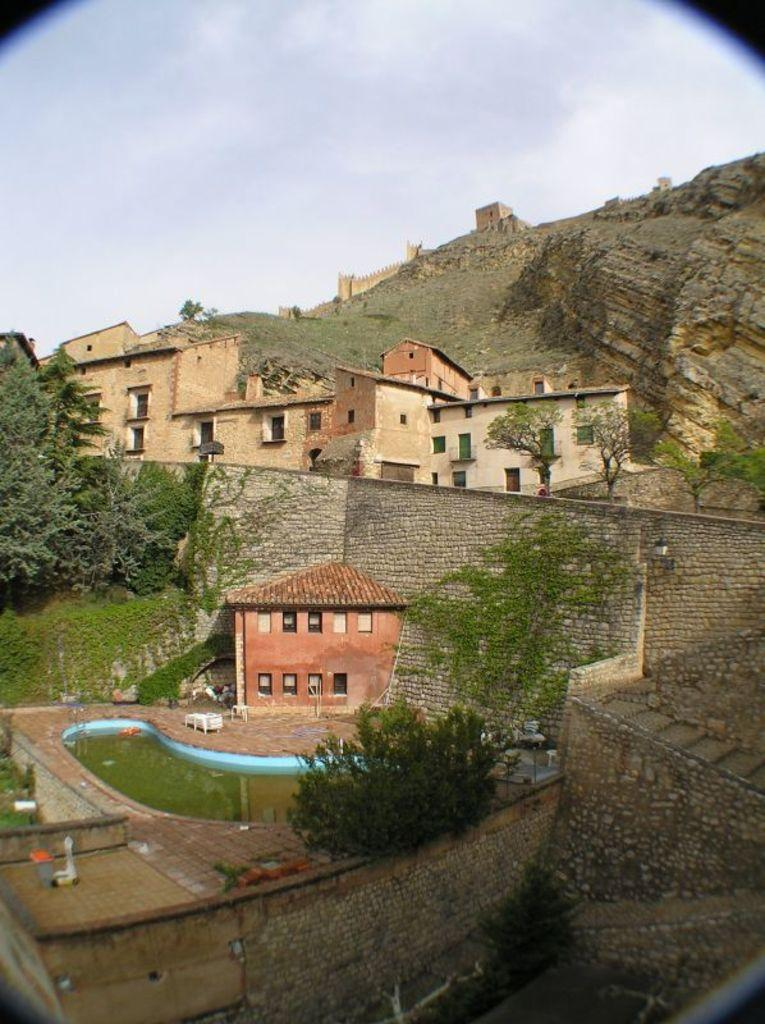What can be seen in the foreground of the image? In the foreground of the image, there are trees, houses, a swimming pool, a wall, and a cliff. What is visible in the background of the image? The sky is visible in the image. Can you describe the sky in the image? The sky in the image has a cloud visible. What is the opinion of the swimming pool in the image? The image does not express an opinion about the swimming pool; it simply shows its presence in the foreground. Can you tell me how much milk is being poured into the pool in the image? There is no milk being poured into the pool in the image; it is a still image of a swimming pool. 